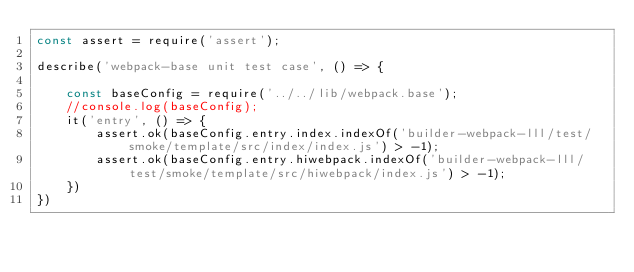<code> <loc_0><loc_0><loc_500><loc_500><_JavaScript_>const assert = require('assert');

describe('webpack-base unit test case', () => {

    const baseConfig = require('../../lib/webpack.base');
    //console.log(baseConfig);
    it('entry', () => {
        assert.ok(baseConfig.entry.index.indexOf('builder-webpack-lll/test/smoke/template/src/index/index.js') > -1);
        assert.ok(baseConfig.entry.hiwebpack.indexOf('builder-webpack-lll/test/smoke/template/src/hiwebpack/index.js') > -1);
    })
})</code> 